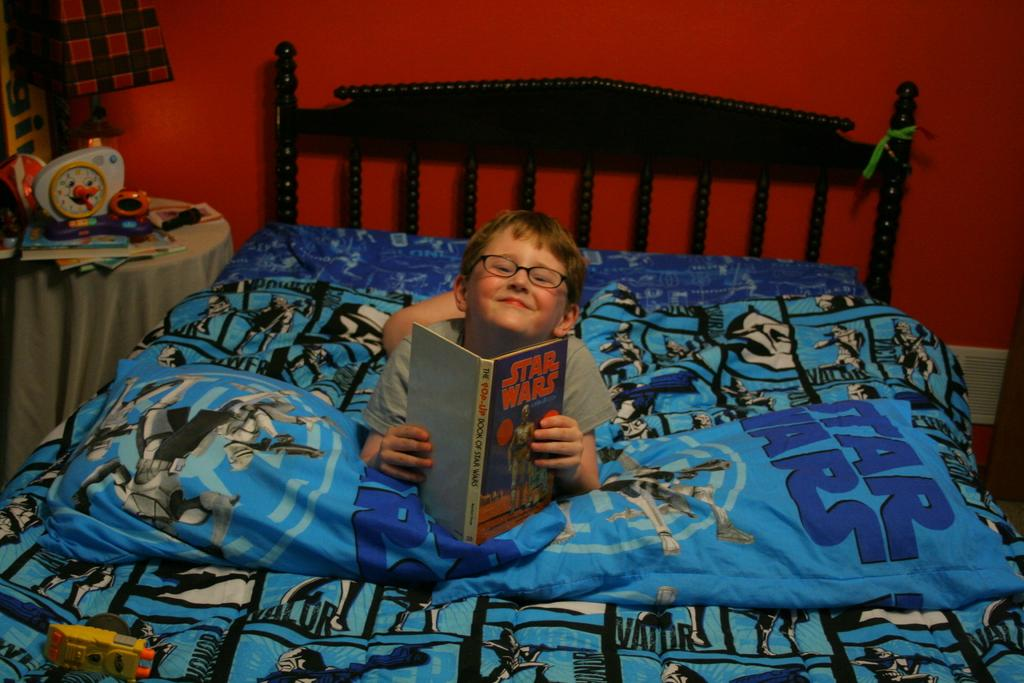What is the main subject of the image? The main subject of the image is a kid. Where is the kid located in the image? The kid is sleeping on a blue bed. What is the kid holding in the image? The kid is holding a book. What is the title of the book the kid is holding? The book has "Star Wars" written on it. What color is the background wall in the image? The background wall is red in color. How many men are visible in the image? There are no men visible in the image; it features a kid sleeping on a blue bed with a "Star Wars" book. What type of error can be seen in the image? There is no error present in the image. 